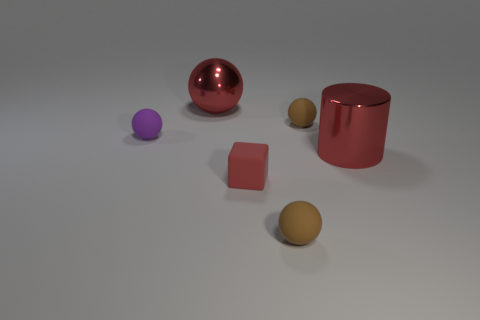There is a metallic cylinder that is the same size as the metallic sphere; what is its color?
Make the answer very short. Red. Is there a big cylinder of the same color as the large metallic sphere?
Your answer should be very brief. Yes. Does the sphere that is to the left of the big sphere have the same size as the red shiny object to the left of the red block?
Give a very brief answer. No. There is a small sphere that is behind the small red matte cube and on the right side of the shiny ball; what is its material?
Your response must be concise. Rubber. The cylinder that is the same color as the large shiny ball is what size?
Give a very brief answer. Large. What number of other objects are there of the same size as the cylinder?
Your answer should be compact. 1. What is the brown sphere in front of the purple rubber sphere made of?
Provide a short and direct response. Rubber. Does the purple object have the same shape as the tiny red rubber thing?
Your answer should be compact. No. How many other things are there of the same shape as the small purple thing?
Offer a very short reply. 3. What color is the rubber ball that is in front of the matte cube?
Provide a succinct answer. Brown. 